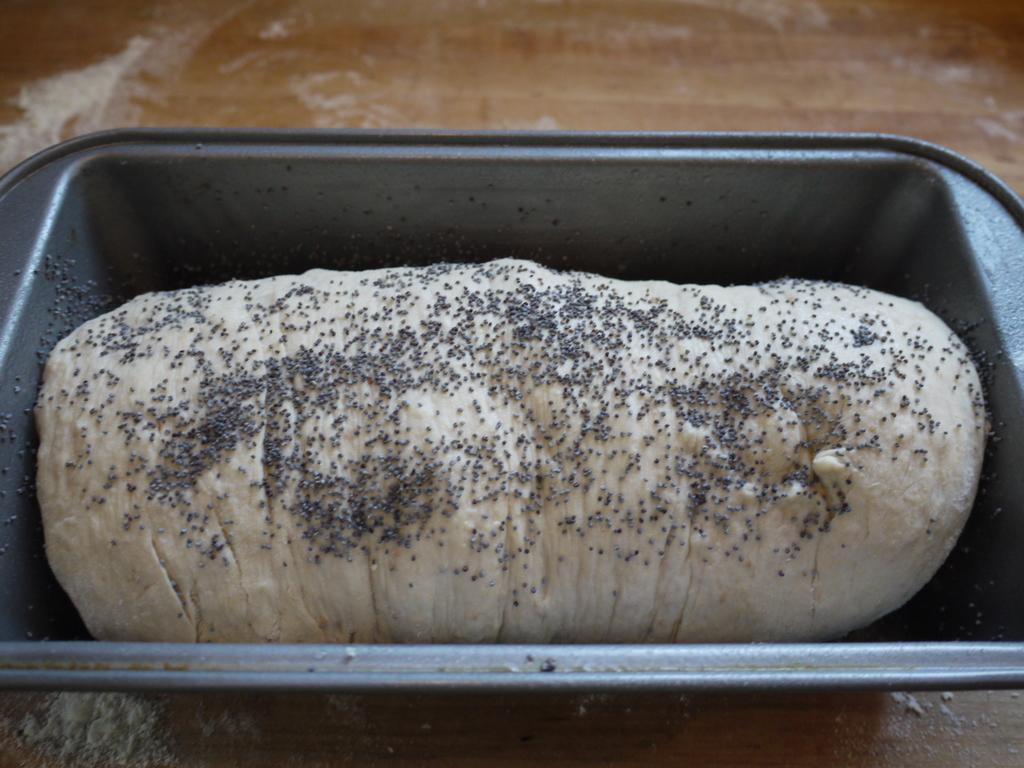What is the main subject in the image? There is a flour dough in a vessel in the image. What is placed on the flour dough? There are seeds on the flour dough. Where are the flour dough and seeds located? Both the flour dough and seeds are on a table. What type of rhythm is being played in the background of the image? There is no indication of any music or rhythm in the image. 